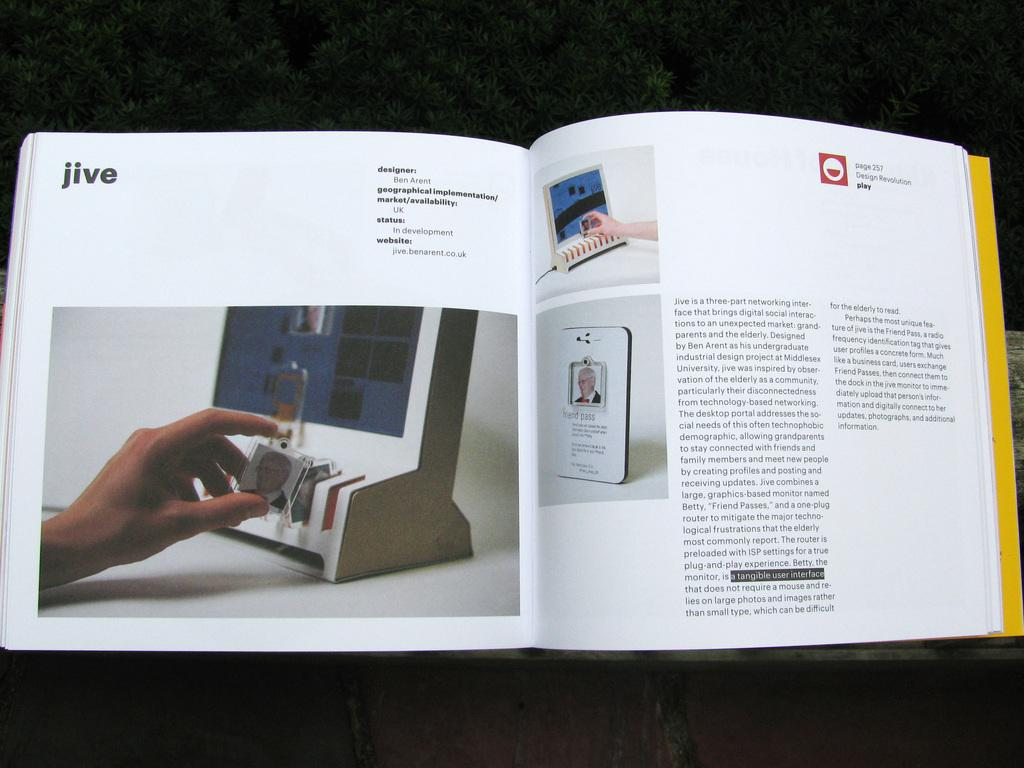<image>
Relay a brief, clear account of the picture shown. A open book about Jive with Design Revolution play logo. 